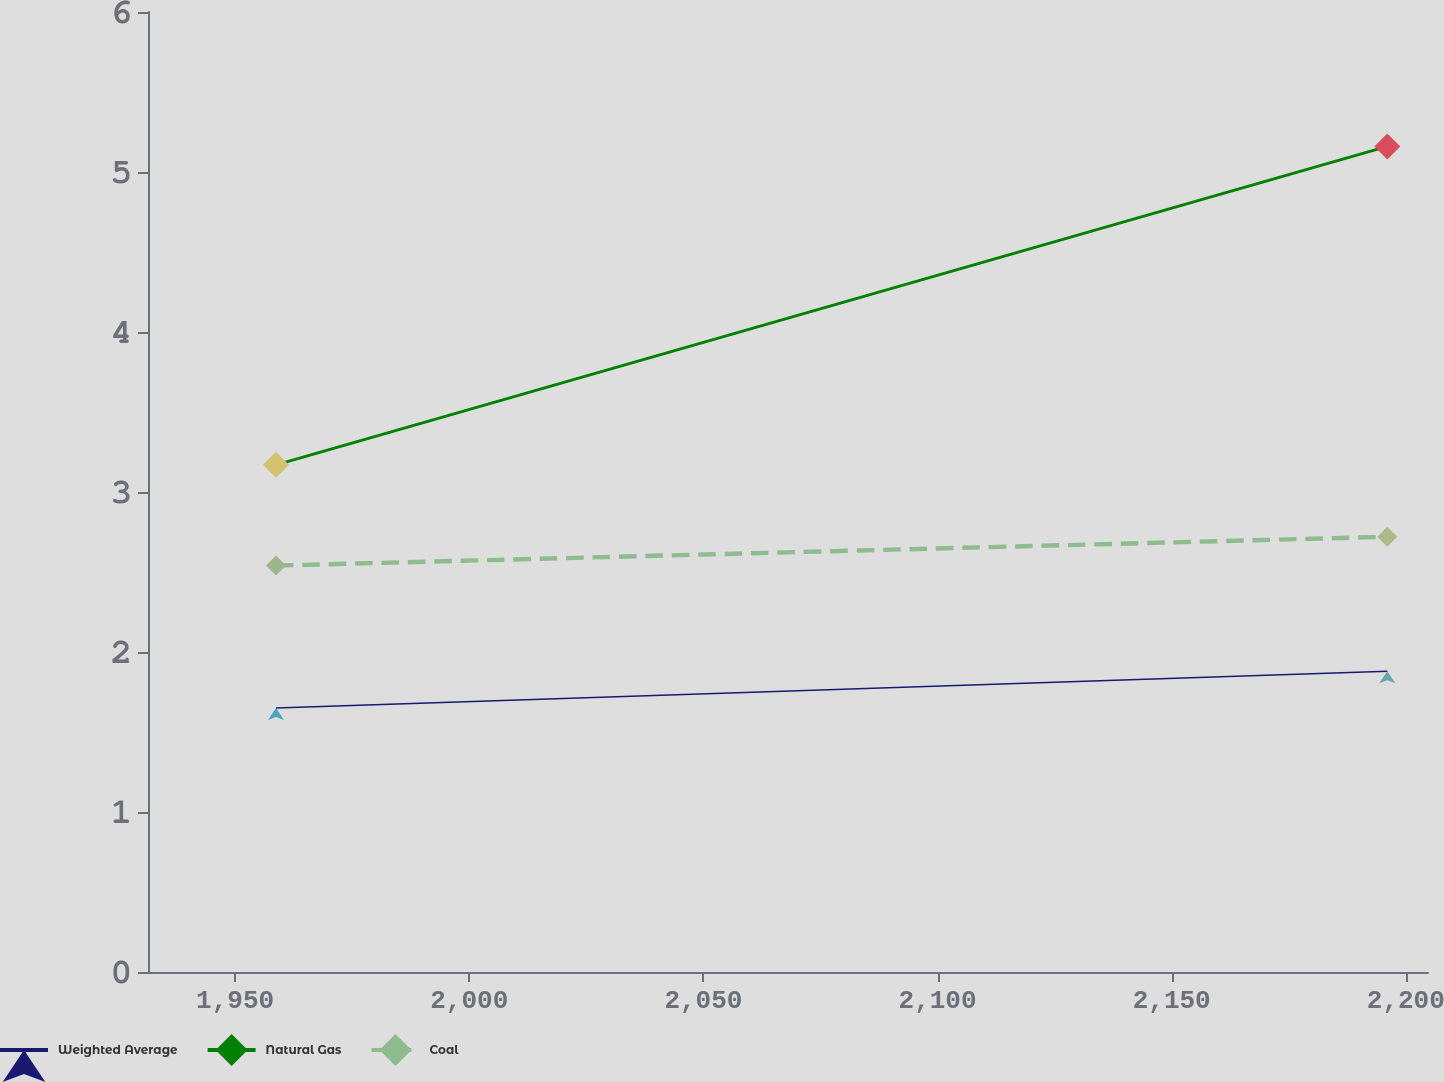Convert chart. <chart><loc_0><loc_0><loc_500><loc_500><line_chart><ecel><fcel>Weighted Average<fcel>Natural Gas<fcel>Coal<nl><fcel>1958.73<fcel>1.65<fcel>3.17<fcel>2.54<nl><fcel>2196.05<fcel>1.88<fcel>5.16<fcel>2.72<nl><fcel>2232.07<fcel>1.71<fcel>4.58<fcel>2.03<nl></chart> 